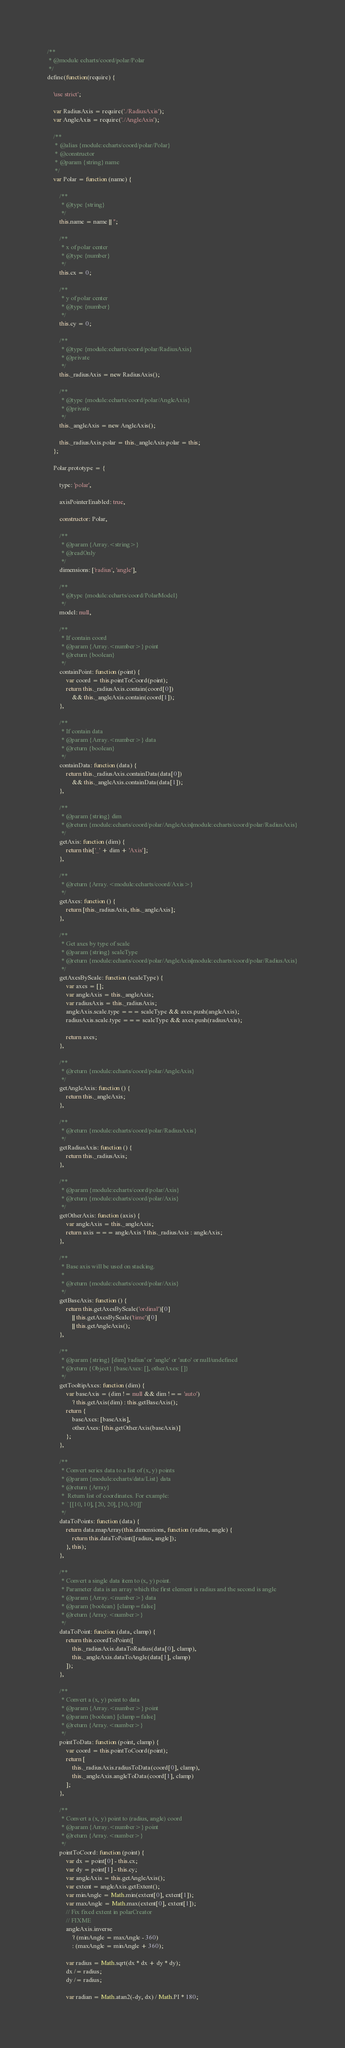<code> <loc_0><loc_0><loc_500><loc_500><_JavaScript_>/**
 * @module echarts/coord/polar/Polar
 */
define(function(require) {

    'use strict';

    var RadiusAxis = require('./RadiusAxis');
    var AngleAxis = require('./AngleAxis');

    /**
     * @alias {module:echarts/coord/polar/Polar}
     * @constructor
     * @param {string} name
     */
    var Polar = function (name) {

        /**
         * @type {string}
         */
        this.name = name || '';

        /**
         * x of polar center
         * @type {number}
         */
        this.cx = 0;

        /**
         * y of polar center
         * @type {number}
         */
        this.cy = 0;

        /**
         * @type {module:echarts/coord/polar/RadiusAxis}
         * @private
         */
        this._radiusAxis = new RadiusAxis();

        /**
         * @type {module:echarts/coord/polar/AngleAxis}
         * @private
         */
        this._angleAxis = new AngleAxis();

        this._radiusAxis.polar = this._angleAxis.polar = this;
    };

    Polar.prototype = {

        type: 'polar',

        axisPointerEnabled: true,

        constructor: Polar,

        /**
         * @param {Array.<string>}
         * @readOnly
         */
        dimensions: ['radius', 'angle'],

        /**
         * @type {module:echarts/coord/PolarModel}
         */
        model: null,

        /**
         * If contain coord
         * @param {Array.<number>} point
         * @return {boolean}
         */
        containPoint: function (point) {
            var coord = this.pointToCoord(point);
            return this._radiusAxis.contain(coord[0])
                && this._angleAxis.contain(coord[1]);
        },

        /**
         * If contain data
         * @param {Array.<number>} data
         * @return {boolean}
         */
        containData: function (data) {
            return this._radiusAxis.containData(data[0])
                && this._angleAxis.containData(data[1]);
        },

        /**
         * @param {string} dim
         * @return {module:echarts/coord/polar/AngleAxis|module:echarts/coord/polar/RadiusAxis}
         */
        getAxis: function (dim) {
            return this['_' + dim + 'Axis'];
        },

        /**
         * @return {Array.<module:echarts/coord/Axis>}
         */
        getAxes: function () {
            return [this._radiusAxis, this._angleAxis];
        },

        /**
         * Get axes by type of scale
         * @param {string} scaleType
         * @return {module:echarts/coord/polar/AngleAxis|module:echarts/coord/polar/RadiusAxis}
         */
        getAxesByScale: function (scaleType) {
            var axes = [];
            var angleAxis = this._angleAxis;
            var radiusAxis = this._radiusAxis;
            angleAxis.scale.type === scaleType && axes.push(angleAxis);
            radiusAxis.scale.type === scaleType && axes.push(radiusAxis);

            return axes;
        },

        /**
         * @return {module:echarts/coord/polar/AngleAxis}
         */
        getAngleAxis: function () {
            return this._angleAxis;
        },

        /**
         * @return {module:echarts/coord/polar/RadiusAxis}
         */
        getRadiusAxis: function () {
            return this._radiusAxis;
        },

        /**
         * @param {module:echarts/coord/polar/Axis}
         * @return {module:echarts/coord/polar/Axis}
         */
        getOtherAxis: function (axis) {
            var angleAxis = this._angleAxis;
            return axis === angleAxis ? this._radiusAxis : angleAxis;
        },

        /**
         * Base axis will be used on stacking.
         *
         * @return {module:echarts/coord/polar/Axis}
         */
        getBaseAxis: function () {
            return this.getAxesByScale('ordinal')[0]
                || this.getAxesByScale('time')[0]
                || this.getAngleAxis();
        },

        /**
         * @param {string} [dim] 'radius' or 'angle' or 'auto' or null/undefined
         * @return {Object} {baseAxes: [], otherAxes: []}
         */
        getTooltipAxes: function (dim) {
            var baseAxis = (dim != null && dim !== 'auto')
                ? this.getAxis(dim) : this.getBaseAxis();
            return {
                baseAxes: [baseAxis],
                otherAxes: [this.getOtherAxis(baseAxis)]
            };
        },

        /**
         * Convert series data to a list of (x, y) points
         * @param {module:echarts/data/List} data
         * @return {Array}
         *  Return list of coordinates. For example:
         *  `[[10, 10], [20, 20], [30, 30]]`
         */
        dataToPoints: function (data) {
            return data.mapArray(this.dimensions, function (radius, angle) {
                return this.dataToPoint([radius, angle]);
            }, this);
        },

        /**
         * Convert a single data item to (x, y) point.
         * Parameter data is an array which the first element is radius and the second is angle
         * @param {Array.<number>} data
         * @param {boolean} [clamp=false]
         * @return {Array.<number>}
         */
        dataToPoint: function (data, clamp) {
            return this.coordToPoint([
                this._radiusAxis.dataToRadius(data[0], clamp),
                this._angleAxis.dataToAngle(data[1], clamp)
            ]);
        },

        /**
         * Convert a (x, y) point to data
         * @param {Array.<number>} point
         * @param {boolean} [clamp=false]
         * @return {Array.<number>}
         */
        pointToData: function (point, clamp) {
            var coord = this.pointToCoord(point);
            return [
                this._radiusAxis.radiusToData(coord[0], clamp),
                this._angleAxis.angleToData(coord[1], clamp)
            ];
        },

        /**
         * Convert a (x, y) point to (radius, angle) coord
         * @param {Array.<number>} point
         * @return {Array.<number>}
         */
        pointToCoord: function (point) {
            var dx = point[0] - this.cx;
            var dy = point[1] - this.cy;
            var angleAxis = this.getAngleAxis();
            var extent = angleAxis.getExtent();
            var minAngle = Math.min(extent[0], extent[1]);
            var maxAngle = Math.max(extent[0], extent[1]);
            // Fix fixed extent in polarCreator
            // FIXME
            angleAxis.inverse
                ? (minAngle = maxAngle - 360)
                : (maxAngle = minAngle + 360);

            var radius = Math.sqrt(dx * dx + dy * dy);
            dx /= radius;
            dy /= radius;

            var radian = Math.atan2(-dy, dx) / Math.PI * 180;
</code> 